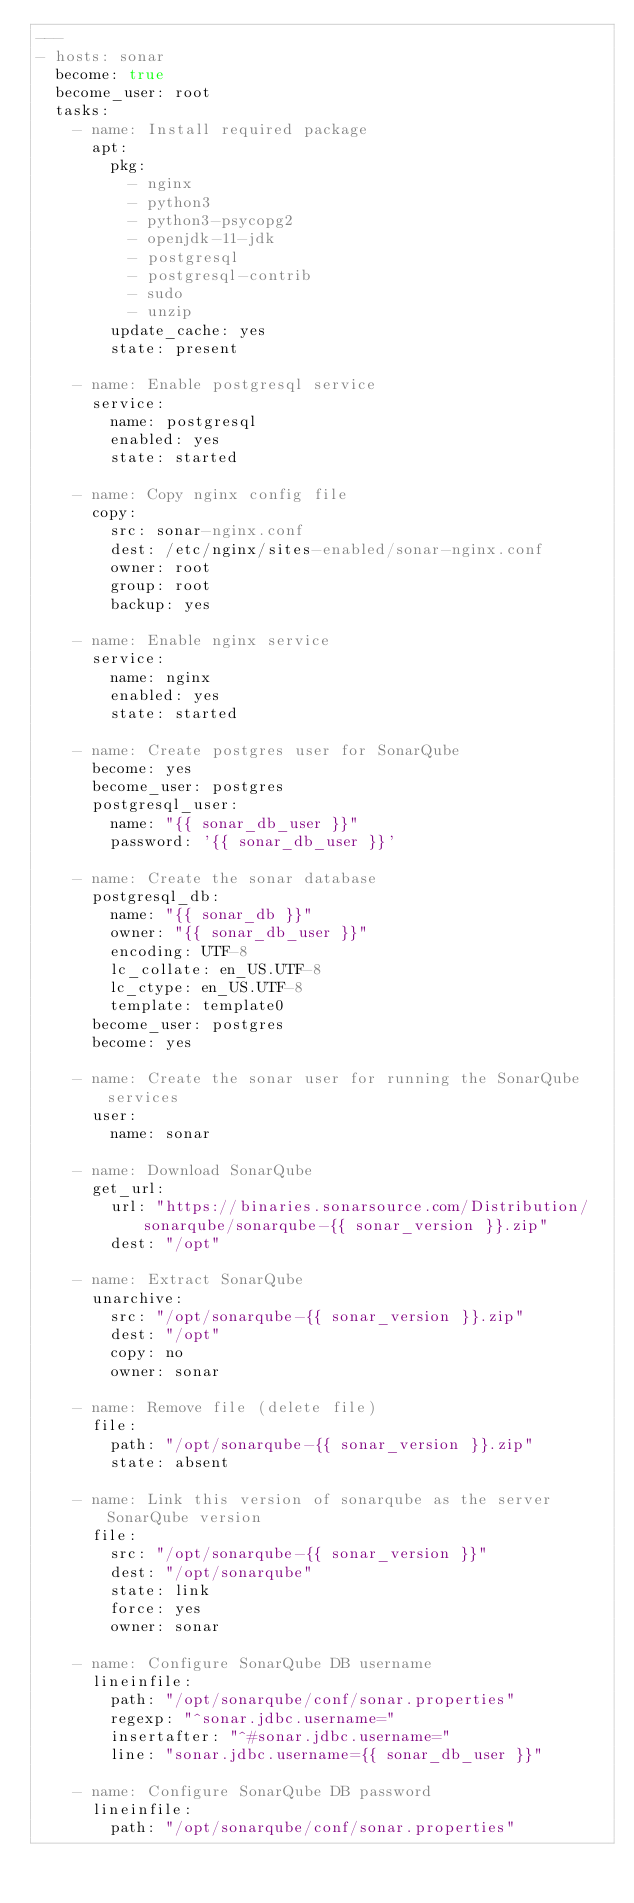<code> <loc_0><loc_0><loc_500><loc_500><_YAML_>---
- hosts: sonar
  become: true
  become_user: root
  tasks:
    - name: Install required package
      apt:
        pkg:
          - nginx
          - python3
          - python3-psycopg2
          - openjdk-11-jdk
          - postgresql
          - postgresql-contrib
          - sudo
          - unzip
        update_cache: yes
        state: present

    - name: Enable postgresql service
      service:
        name: postgresql
        enabled: yes
        state: started

    - name: Copy nginx config file
      copy:
        src: sonar-nginx.conf
        dest: /etc/nginx/sites-enabled/sonar-nginx.conf
        owner: root
        group: root
        backup: yes

    - name: Enable nginx service
      service:
        name: nginx
        enabled: yes
        state: started

    - name: Create postgres user for SonarQube
      become: yes
      become_user: postgres
      postgresql_user:
        name: "{{ sonar_db_user }}"
        password: '{{ sonar_db_user }}'

    - name: Create the sonar database
      postgresql_db:
        name: "{{ sonar_db }}"
        owner: "{{ sonar_db_user }}"
        encoding: UTF-8
        lc_collate: en_US.UTF-8
        lc_ctype: en_US.UTF-8
        template: template0
      become_user: postgres
      become: yes

    - name: Create the sonar user for running the SonarQube services
      user:
        name: sonar

    - name: Download SonarQube
      get_url:
        url: "https://binaries.sonarsource.com/Distribution/sonarqube/sonarqube-{{ sonar_version }}.zip"
        dest: "/opt"

    - name: Extract SonarQube
      unarchive:
        src: "/opt/sonarqube-{{ sonar_version }}.zip"
        dest: "/opt"
        copy: no
        owner: sonar

    - name: Remove file (delete file)
      file:
        path: "/opt/sonarqube-{{ sonar_version }}.zip"
        state: absent

    - name: Link this version of sonarqube as the server SonarQube version
      file:
        src: "/opt/sonarqube-{{ sonar_version }}"
        dest: "/opt/sonarqube"
        state: link
        force: yes
        owner: sonar

    - name: Configure SonarQube DB username
      lineinfile:
        path: "/opt/sonarqube/conf/sonar.properties"
        regexp: "^sonar.jdbc.username="
        insertafter: "^#sonar.jdbc.username="
        line: "sonar.jdbc.username={{ sonar_db_user }}"

    - name: Configure SonarQube DB password
      lineinfile:
        path: "/opt/sonarqube/conf/sonar.properties"</code> 